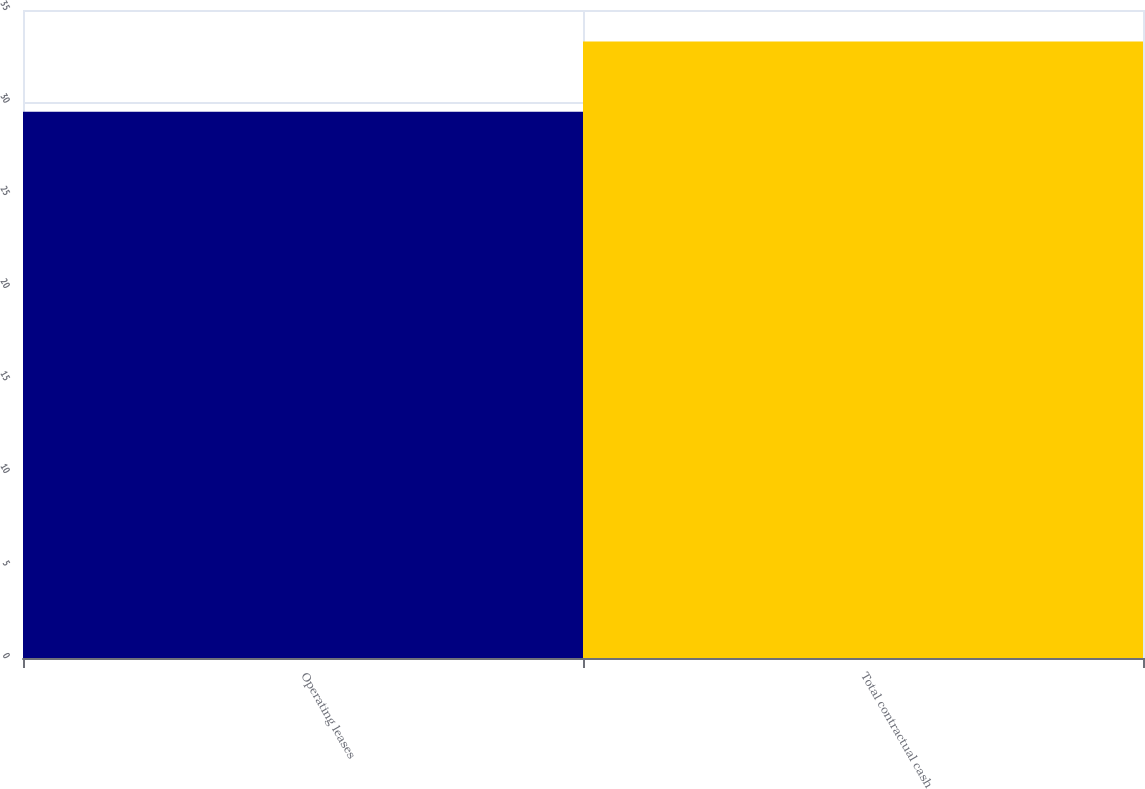Convert chart to OTSL. <chart><loc_0><loc_0><loc_500><loc_500><bar_chart><fcel>Operating leases<fcel>Total contractual cash<nl><fcel>29.5<fcel>33.3<nl></chart> 